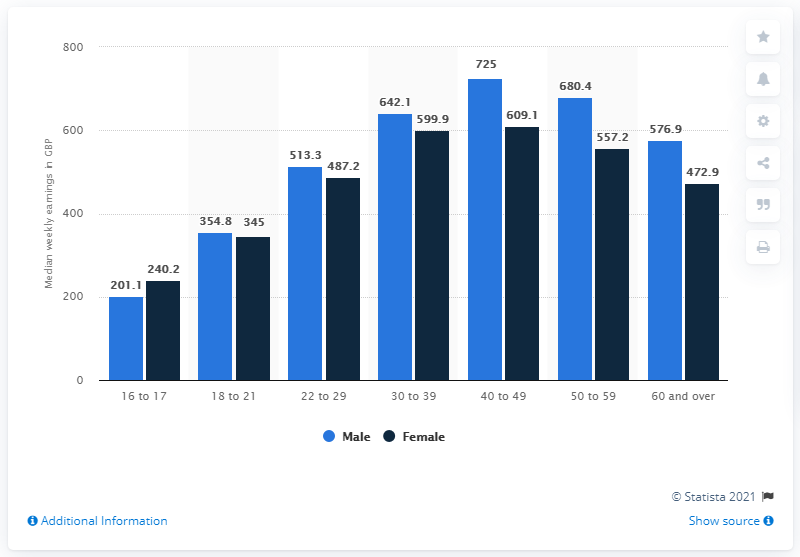Draw attention to some important aspects in this diagram. The light blue colored bar represents the highest value. The age group that shows the greatest difference in earnings between male and female employees is 50 to 59 years old. 